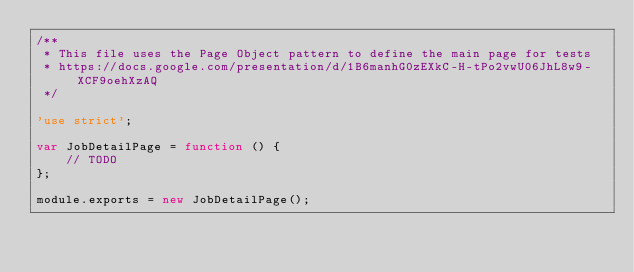<code> <loc_0><loc_0><loc_500><loc_500><_JavaScript_>/**
 * This file uses the Page Object pattern to define the main page for tests
 * https://docs.google.com/presentation/d/1B6manhG0zEXkC-H-tPo2vwU06JhL8w9-XCF9oehXzAQ
 */

'use strict';

var JobDetailPage = function () {
    // TODO
};

module.exports = new JobDetailPage();
</code> 